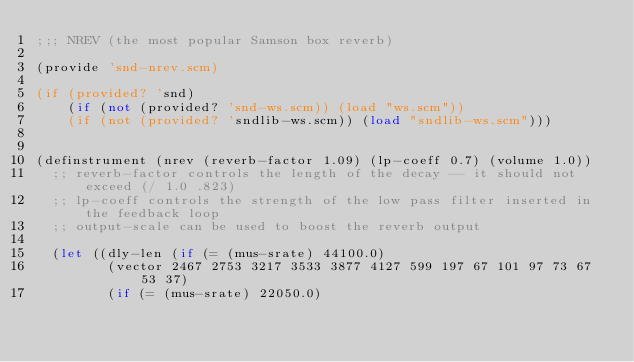<code> <loc_0><loc_0><loc_500><loc_500><_Scheme_>;;; NREV (the most popular Samson box reverb)

(provide 'snd-nrev.scm)

(if (provided? 'snd)
    (if (not (provided? 'snd-ws.scm)) (load "ws.scm"))
    (if (not (provided? 'sndlib-ws.scm)) (load "sndlib-ws.scm")))


(definstrument (nrev (reverb-factor 1.09) (lp-coeff 0.7) (volume 1.0))
  ;; reverb-factor controls the length of the decay -- it should not exceed (/ 1.0 .823)
  ;; lp-coeff controls the strength of the low pass filter inserted in the feedback loop
  ;; output-scale can be used to boost the reverb output

  (let ((dly-len (if (= (mus-srate) 44100.0)
		     (vector 2467 2753 3217 3533 3877 4127 599 197 67 101 97 73 67 53 37)
		     (if (= (mus-srate) 22050.0)</code> 